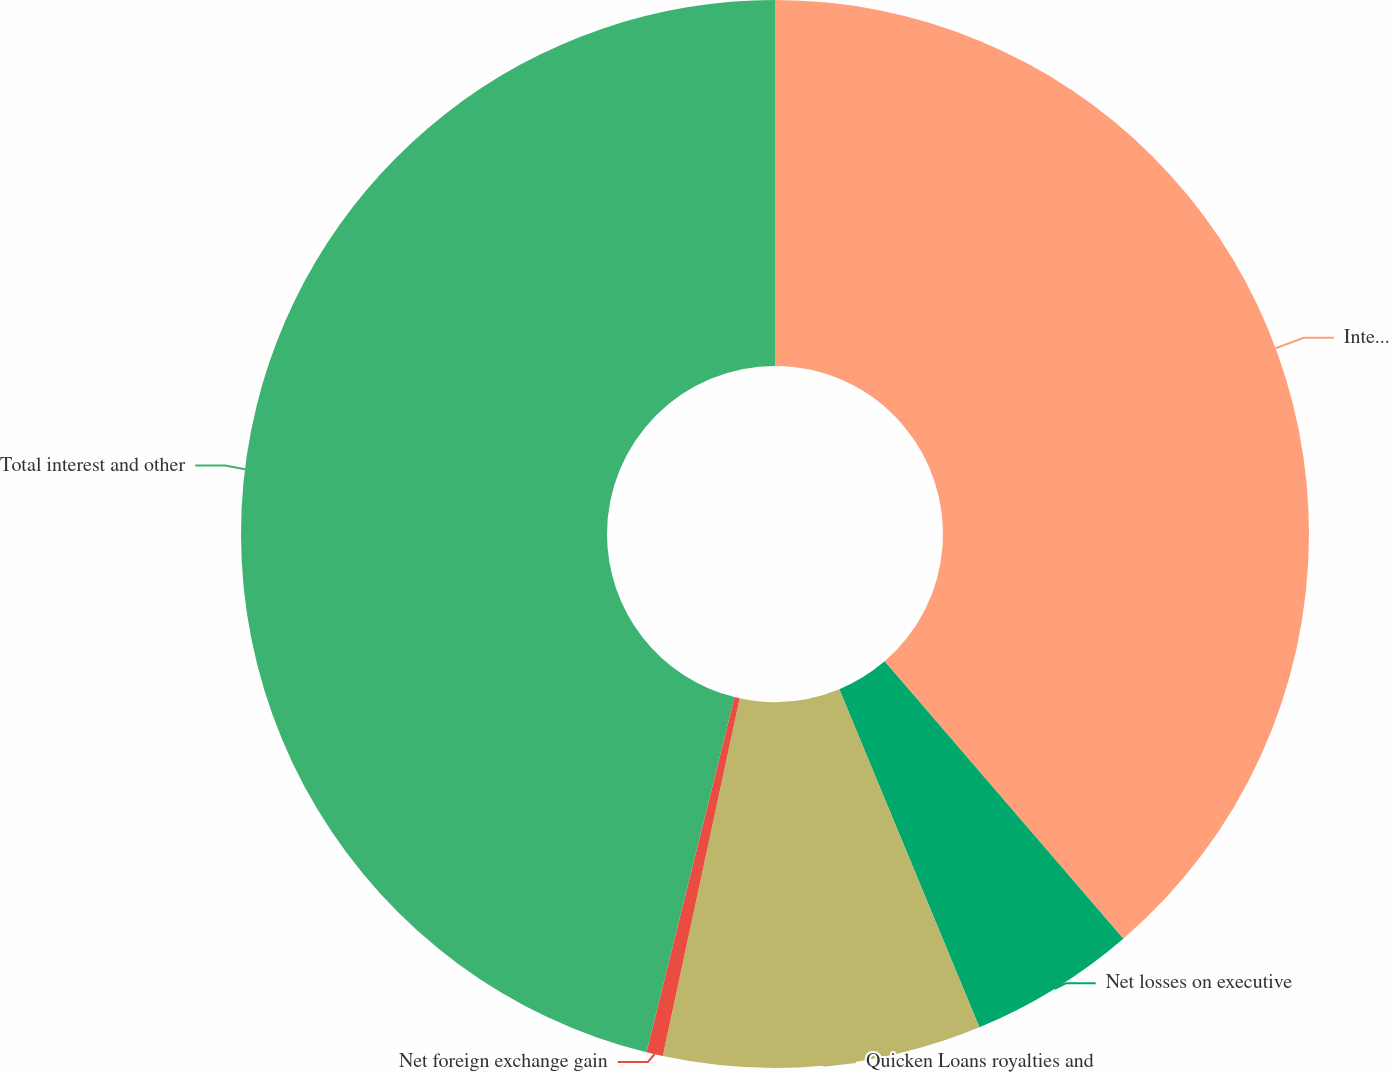<chart> <loc_0><loc_0><loc_500><loc_500><pie_chart><fcel>Interest income<fcel>Net losses on executive<fcel>Quicken Loans royalties and<fcel>Net foreign exchange gain<fcel>Total interest and other<nl><fcel>38.69%<fcel>5.06%<fcel>9.62%<fcel>0.5%<fcel>46.13%<nl></chart> 